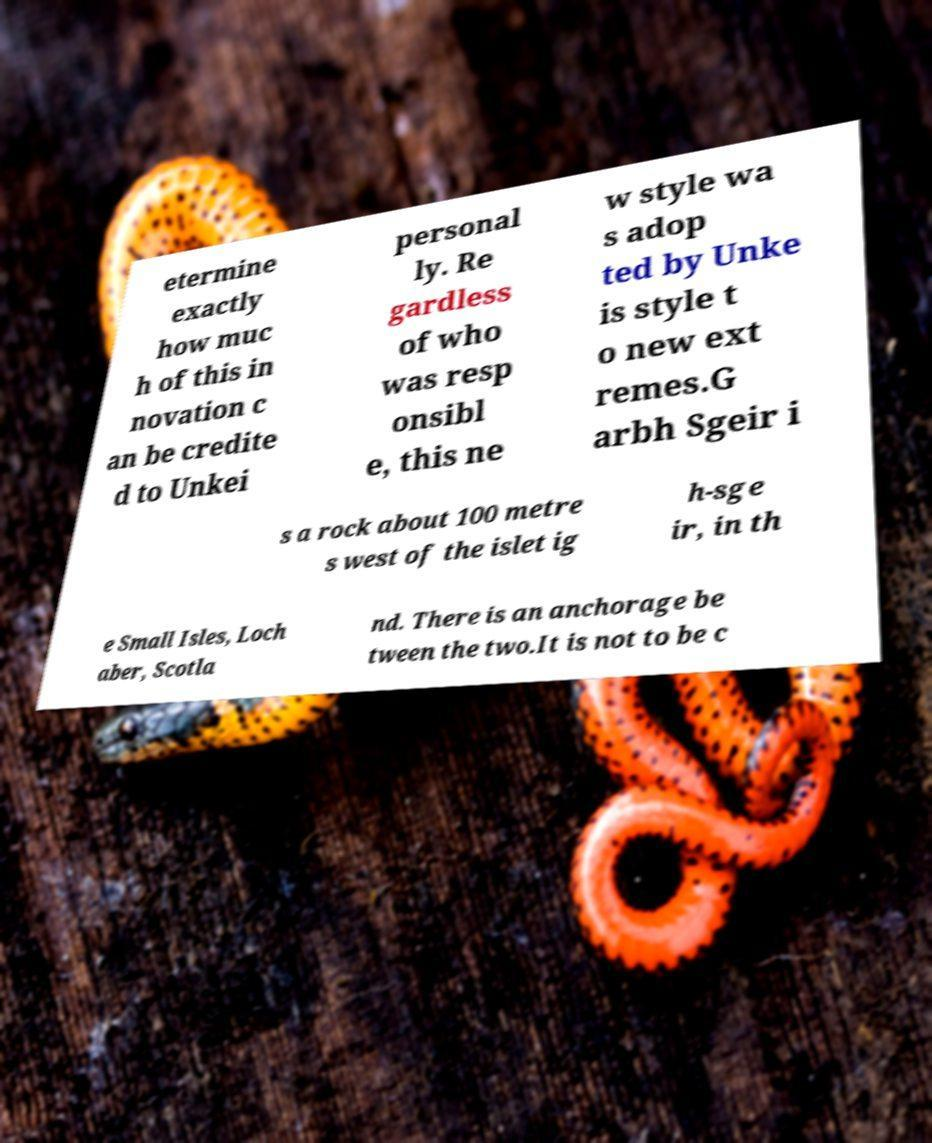Please read and relay the text visible in this image. What does it say? etermine exactly how muc h of this in novation c an be credite d to Unkei personal ly. Re gardless of who was resp onsibl e, this ne w style wa s adop ted by Unke is style t o new ext remes.G arbh Sgeir i s a rock about 100 metre s west of the islet ig h-sge ir, in th e Small Isles, Loch aber, Scotla nd. There is an anchorage be tween the two.It is not to be c 